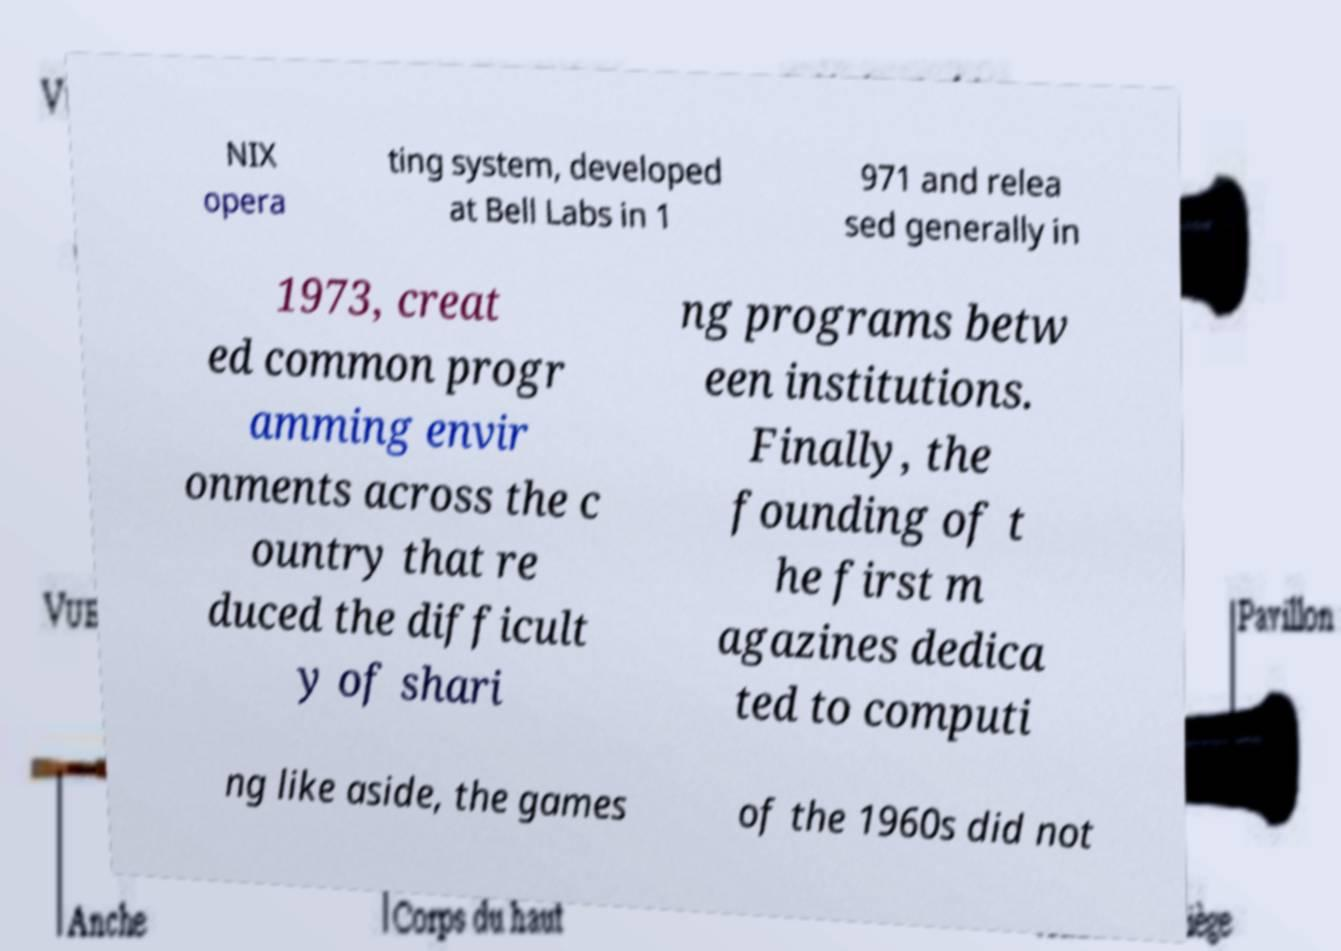What messages or text are displayed in this image? I need them in a readable, typed format. NIX opera ting system, developed at Bell Labs in 1 971 and relea sed generally in 1973, creat ed common progr amming envir onments across the c ountry that re duced the difficult y of shari ng programs betw een institutions. Finally, the founding of t he first m agazines dedica ted to computi ng like aside, the games of the 1960s did not 